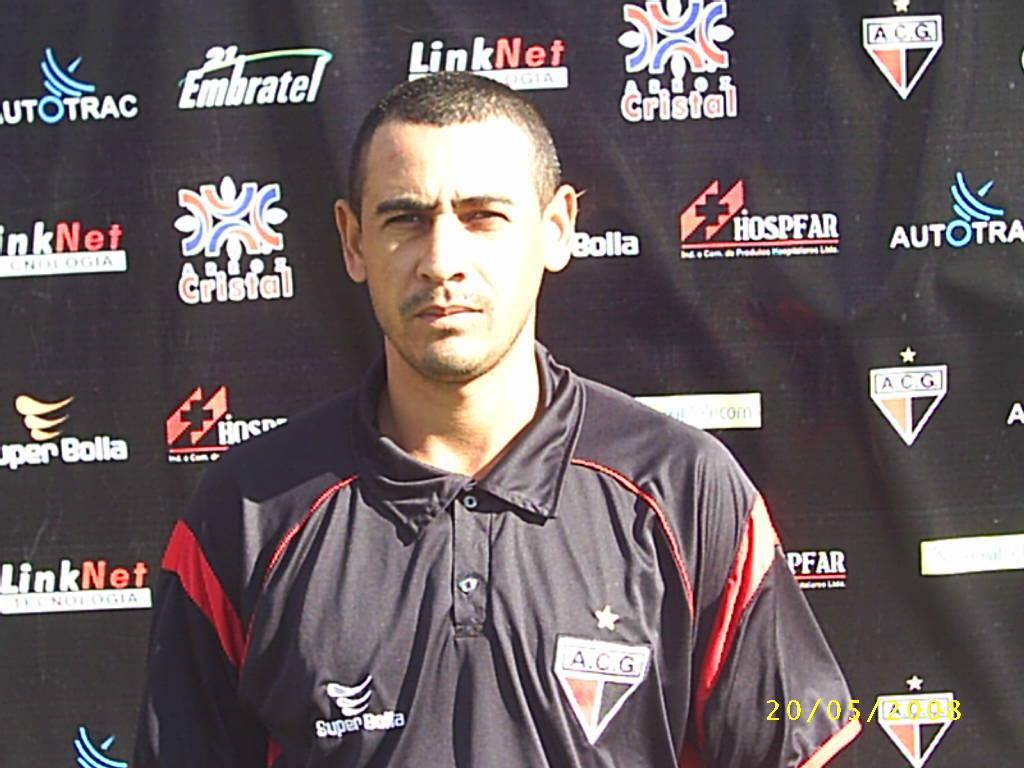<image>
Write a terse but informative summary of the picture. A.C.G. is wriiten on the front the person shirt standing in front of the bill board. 